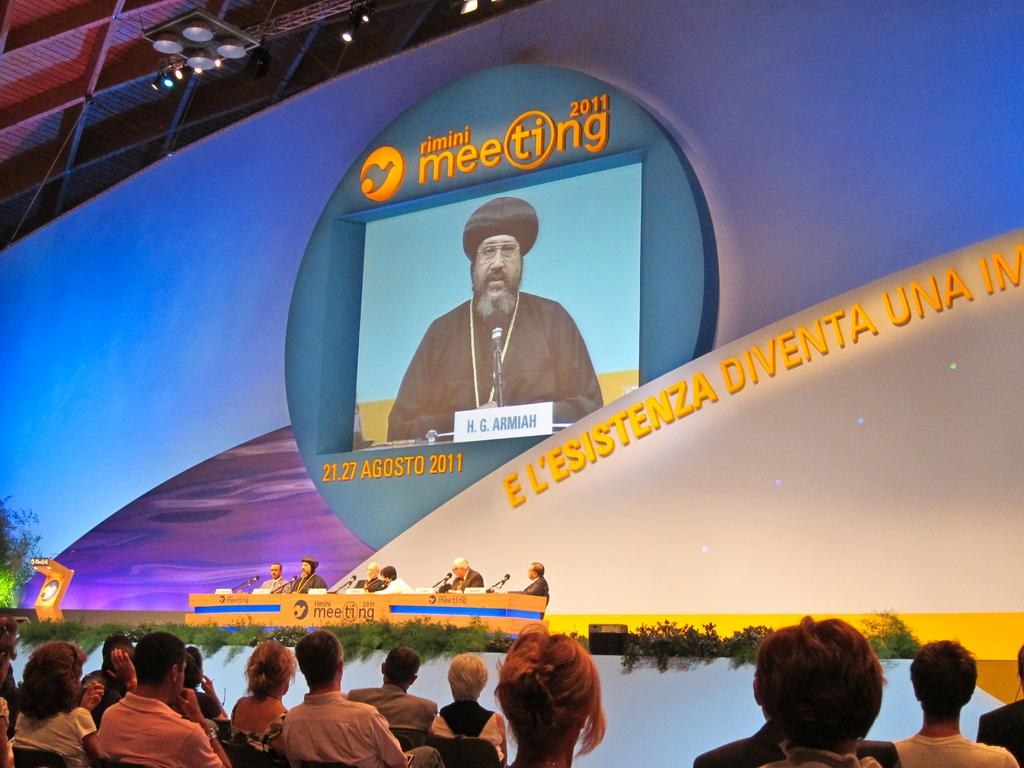<image>
Provide a brief description of the given image. A group panel presentation taking place in 2011 